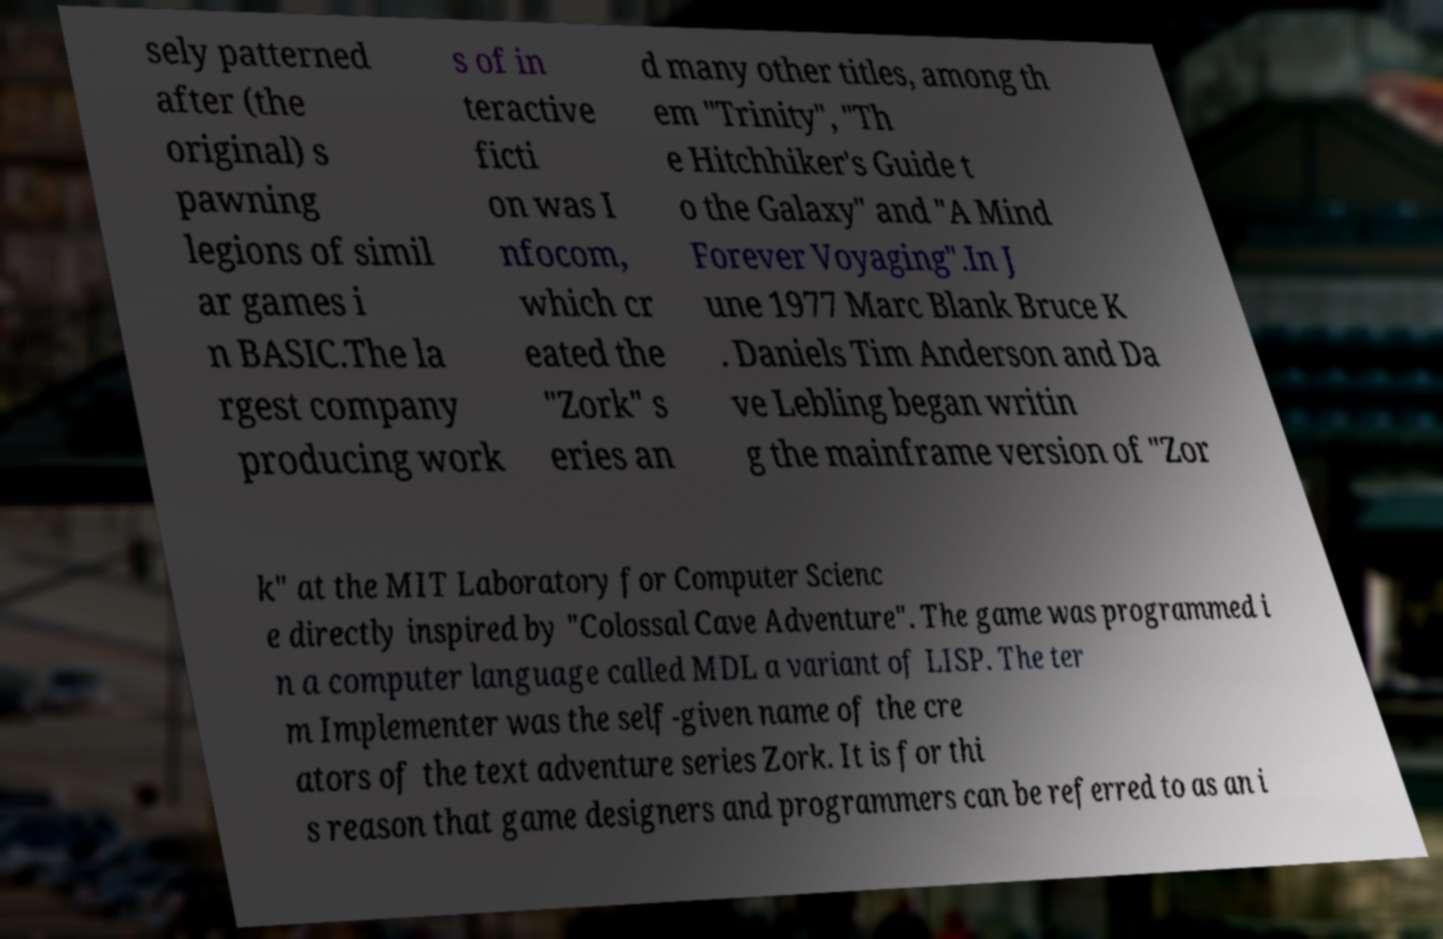For documentation purposes, I need the text within this image transcribed. Could you provide that? sely patterned after (the original) s pawning legions of simil ar games i n BASIC.The la rgest company producing work s of in teractive ficti on was I nfocom, which cr eated the "Zork" s eries an d many other titles, among th em "Trinity", "Th e Hitchhiker's Guide t o the Galaxy" and "A Mind Forever Voyaging".In J une 1977 Marc Blank Bruce K . Daniels Tim Anderson and Da ve Lebling began writin g the mainframe version of "Zor k" at the MIT Laboratory for Computer Scienc e directly inspired by "Colossal Cave Adventure". The game was programmed i n a computer language called MDL a variant of LISP. The ter m Implementer was the self-given name of the cre ators of the text adventure series Zork. It is for thi s reason that game designers and programmers can be referred to as an i 